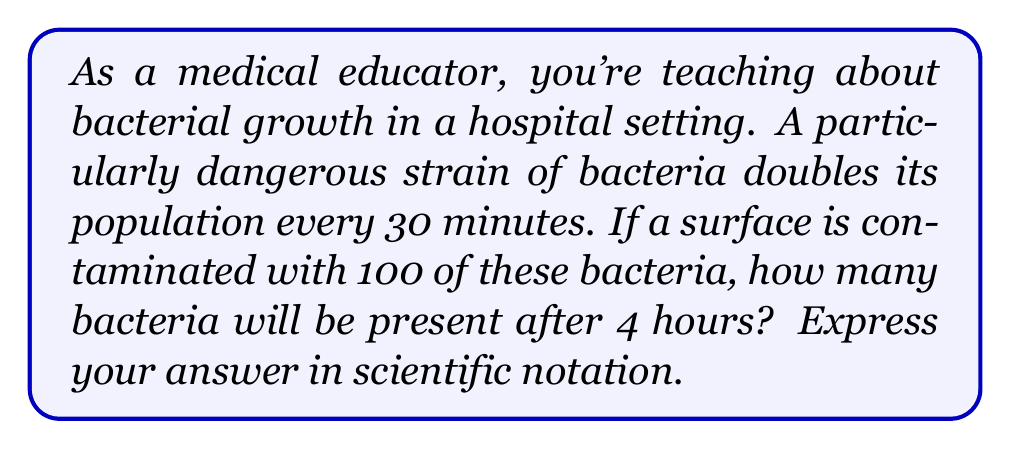Help me with this question. Let's approach this step-by-step:

1) First, we need to determine how many doubling periods occur in 4 hours:
   - 4 hours = 240 minutes
   - Each doubling period is 30 minutes
   - Number of doubling periods = 240 / 30 = 8

2) We can express this as an exponential growth problem:
   $$ N = N_0 \cdot 2^n $$
   Where:
   $N$ = Final number of bacteria
   $N_0$ = Initial number of bacteria (100)
   $2$ = Growth factor (doubling each period)
   $n$ = Number of doubling periods (8)

3) Plugging in our values:
   $$ N = 100 \cdot 2^8 $$

4) Calculate $2^8$:
   $$ 2^8 = 256 $$

5) Multiply:
   $$ N = 100 \cdot 256 = 25,600 $$

6) Express in scientific notation:
   $$ N = 2.56 \times 10^4 $$

This exponential growth demonstrates why controlling bacterial contamination in medical settings is crucial.
Answer: $2.56 \times 10^4$ 